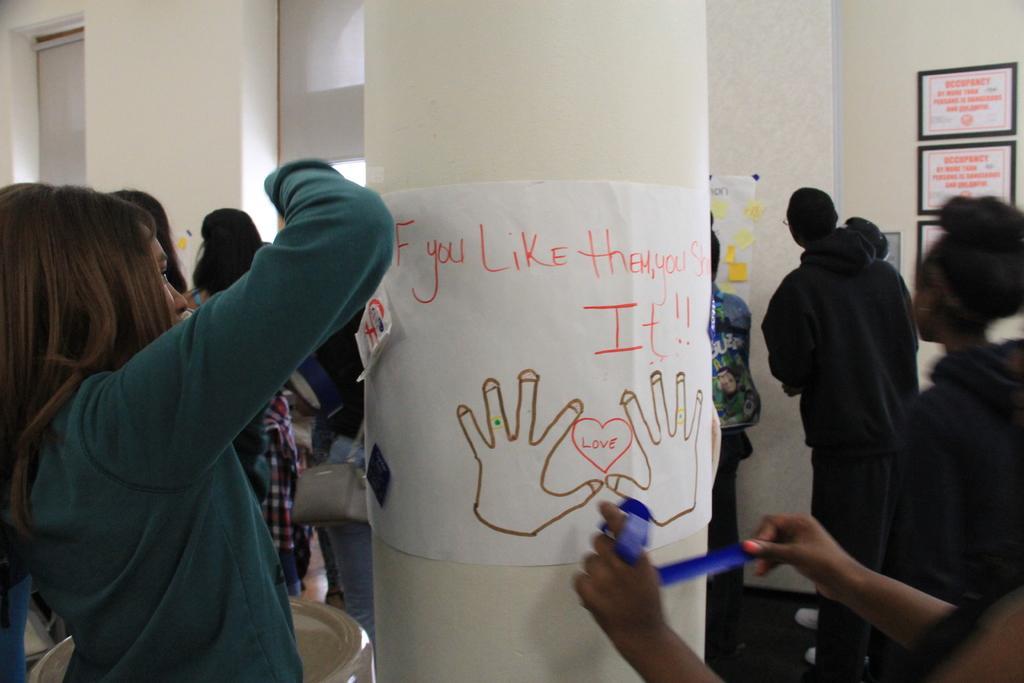Could you give a brief overview of what you see in this image? In this image we can see a group of people are standing ,A person is watching a notice, Here a notice board is displayed. 